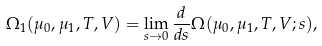Convert formula to latex. <formula><loc_0><loc_0><loc_500><loc_500>\Omega _ { 1 } ( \mu _ { 0 } , \mu _ { 1 } , T , V ) = \lim _ { s \to 0 } \frac { d } { d s } \Omega ( \mu _ { 0 } , \mu _ { 1 } , T , V ; s ) ,</formula> 